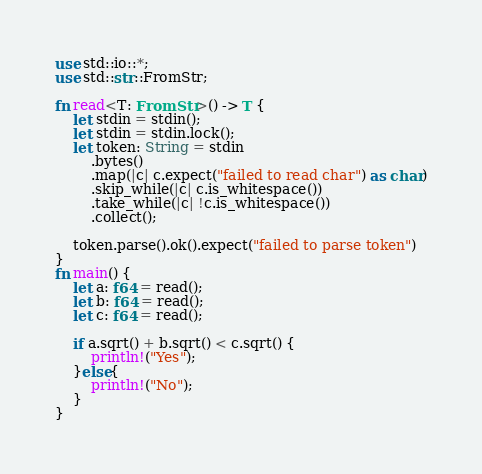<code> <loc_0><loc_0><loc_500><loc_500><_Rust_>use std::io::*;
use std::str::FromStr;

fn read<T: FromStr>() -> T {
    let stdin = stdin();
    let stdin = stdin.lock();
    let token: String = stdin
        .bytes()
        .map(|c| c.expect("failed to read char") as char)
        .skip_while(|c| c.is_whitespace())
        .take_while(|c| !c.is_whitespace())
        .collect();

    token.parse().ok().expect("failed to parse token")
}
fn main() {
    let a: f64 = read();
    let b: f64 = read();
    let c: f64 = read();

    if a.sqrt() + b.sqrt() < c.sqrt() {
        println!("Yes");
    }else{
        println!("No");
    }
}
</code> 